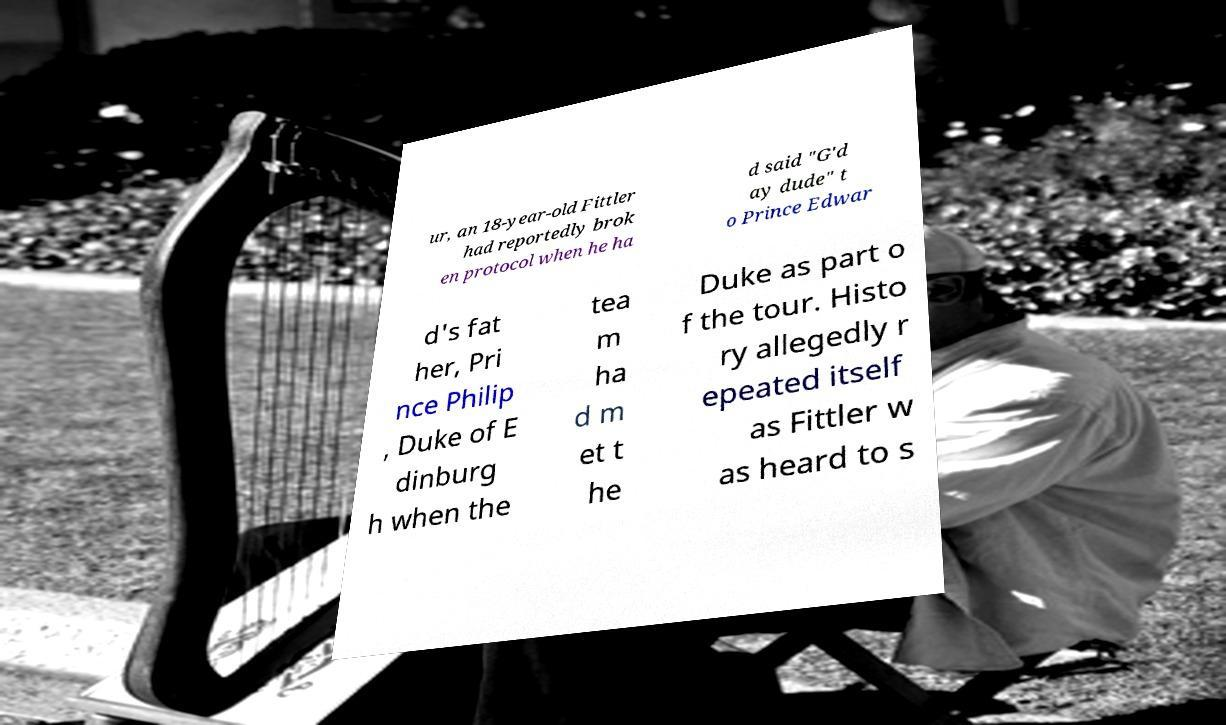Could you extract and type out the text from this image? ur, an 18-year-old Fittler had reportedly brok en protocol when he ha d said "G'd ay dude" t o Prince Edwar d's fat her, Pri nce Philip , Duke of E dinburg h when the tea m ha d m et t he Duke as part o f the tour. Histo ry allegedly r epeated itself as Fittler w as heard to s 